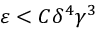Convert formula to latex. <formula><loc_0><loc_0><loc_500><loc_500>\varepsilon < C \delta ^ { 4 } \gamma ^ { 3 }</formula> 